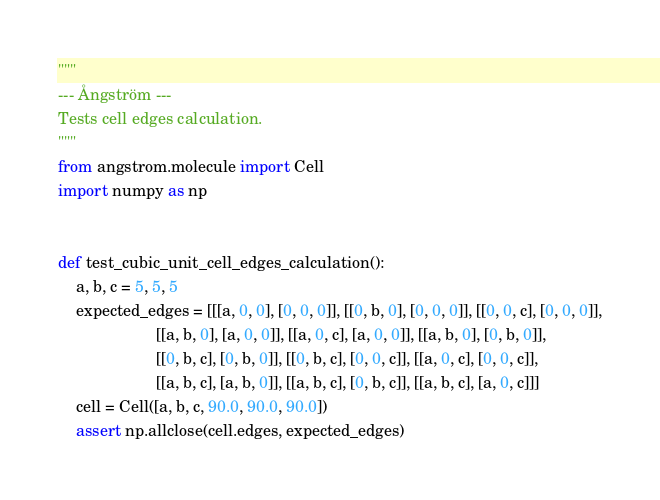<code> <loc_0><loc_0><loc_500><loc_500><_Python_>"""
--- Ångström ---
Tests cell edges calculation.
"""
from angstrom.molecule import Cell
import numpy as np


def test_cubic_unit_cell_edges_calculation():
    a, b, c = 5, 5, 5
    expected_edges = [[[a, 0, 0], [0, 0, 0]], [[0, b, 0], [0, 0, 0]], [[0, 0, c], [0, 0, 0]],
                      [[a, b, 0], [a, 0, 0]], [[a, 0, c], [a, 0, 0]], [[a, b, 0], [0, b, 0]],
                      [[0, b, c], [0, b, 0]], [[0, b, c], [0, 0, c]], [[a, 0, c], [0, 0, c]],
                      [[a, b, c], [a, b, 0]], [[a, b, c], [0, b, c]], [[a, b, c], [a, 0, c]]]
    cell = Cell([a, b, c, 90.0, 90.0, 90.0])
    assert np.allclose(cell.edges, expected_edges)
</code> 